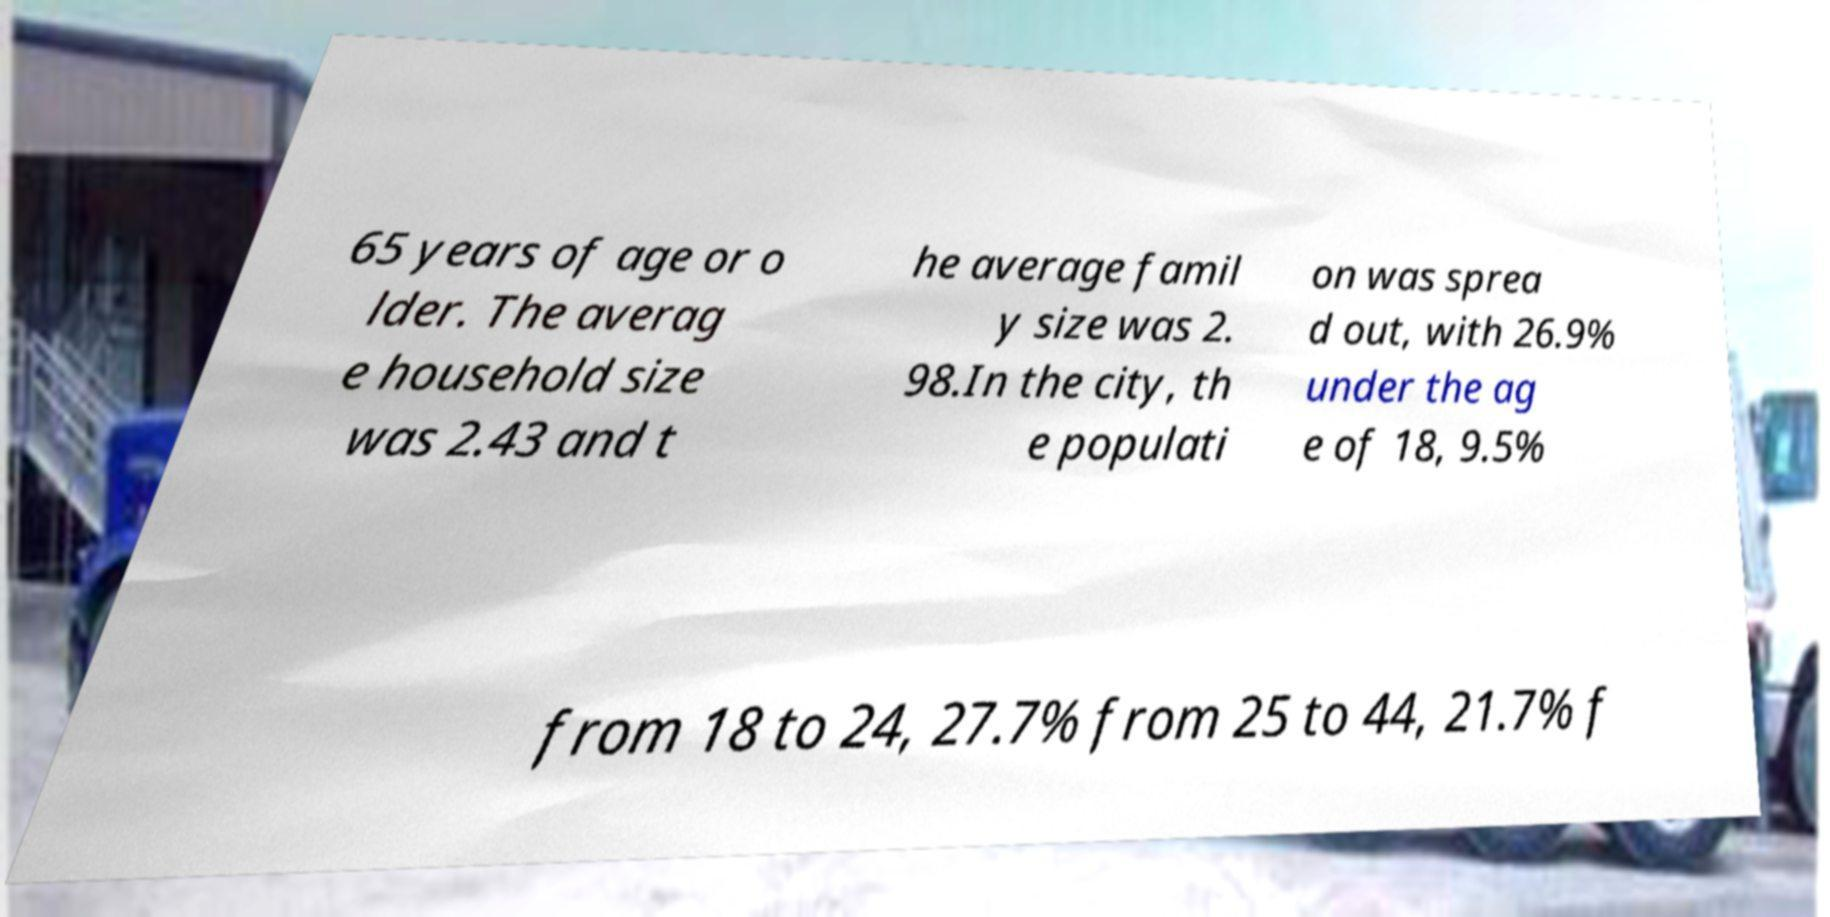Please read and relay the text visible in this image. What does it say? 65 years of age or o lder. The averag e household size was 2.43 and t he average famil y size was 2. 98.In the city, th e populati on was sprea d out, with 26.9% under the ag e of 18, 9.5% from 18 to 24, 27.7% from 25 to 44, 21.7% f 